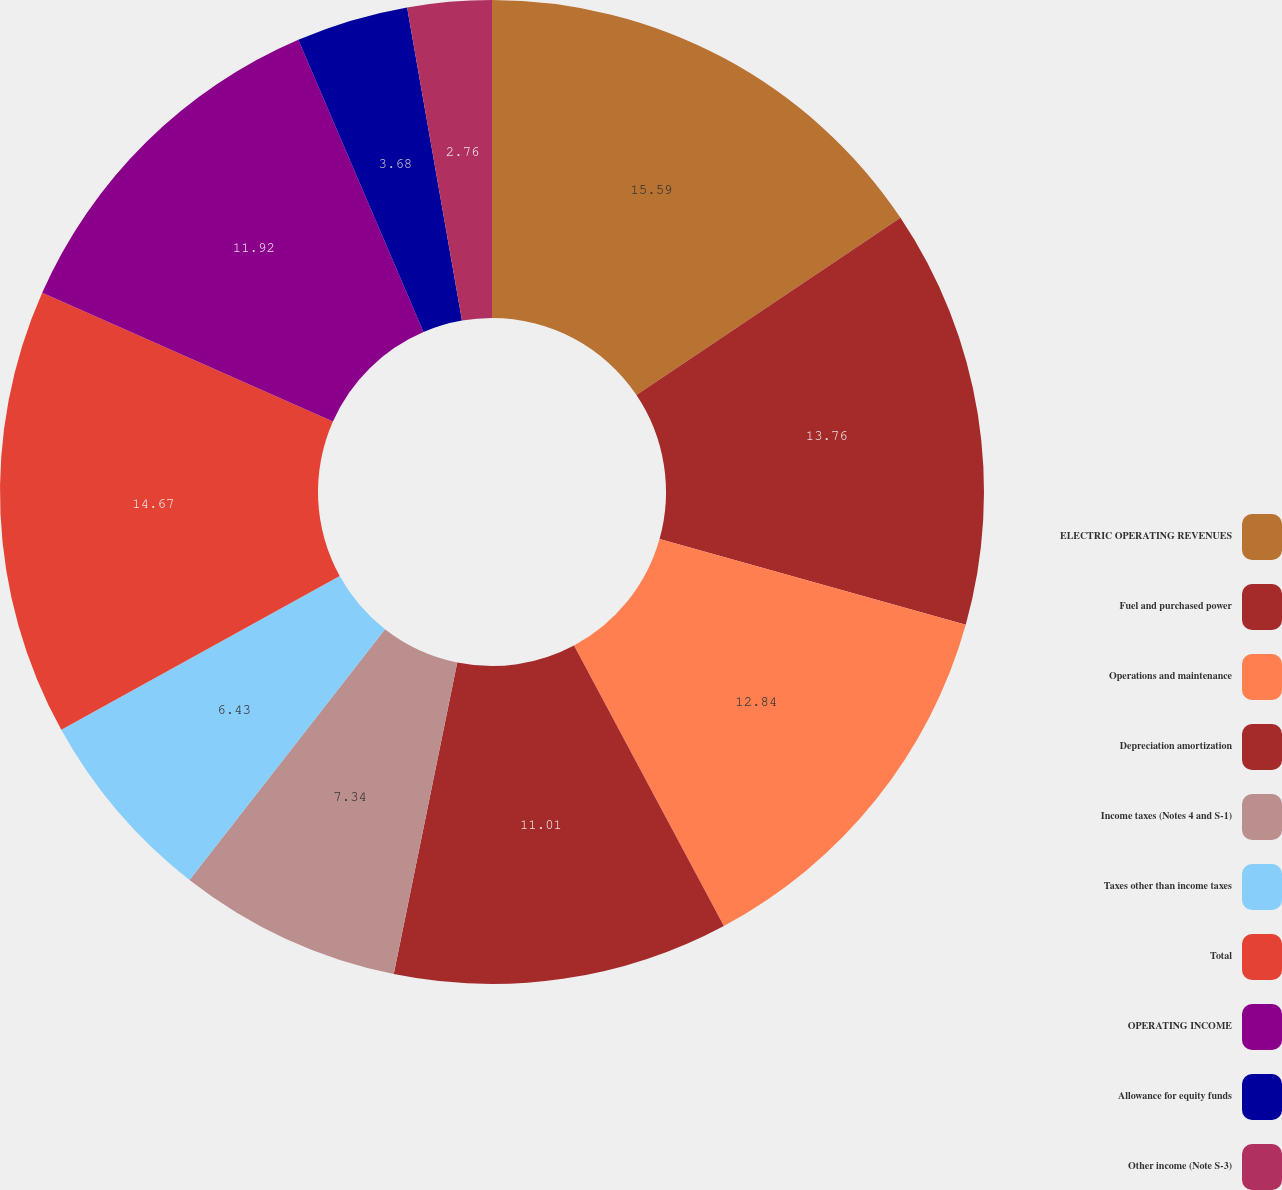<chart> <loc_0><loc_0><loc_500><loc_500><pie_chart><fcel>ELECTRIC OPERATING REVENUES<fcel>Fuel and purchased power<fcel>Operations and maintenance<fcel>Depreciation amortization<fcel>Income taxes (Notes 4 and S-1)<fcel>Taxes other than income taxes<fcel>Total<fcel>OPERATING INCOME<fcel>Allowance for equity funds<fcel>Other income (Note S-3)<nl><fcel>15.59%<fcel>13.76%<fcel>12.84%<fcel>11.01%<fcel>7.34%<fcel>6.43%<fcel>14.67%<fcel>11.92%<fcel>3.68%<fcel>2.76%<nl></chart> 